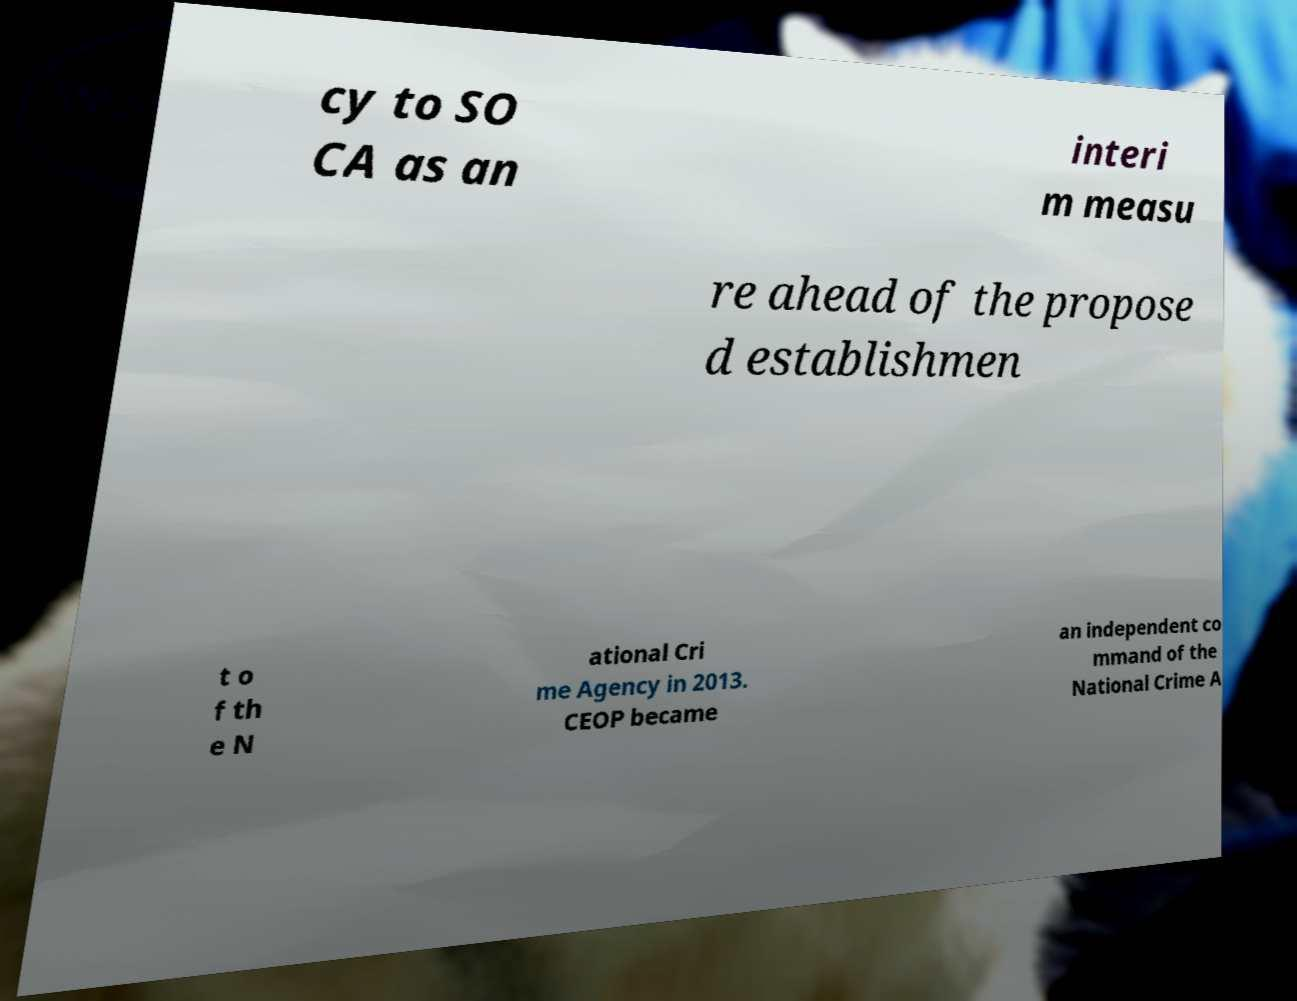Please identify and transcribe the text found in this image. cy to SO CA as an interi m measu re ahead of the propose d establishmen t o f th e N ational Cri me Agency in 2013. CEOP became an independent co mmand of the National Crime A 